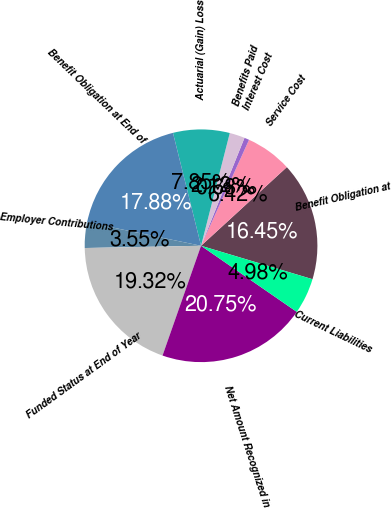Convert chart to OTSL. <chart><loc_0><loc_0><loc_500><loc_500><pie_chart><fcel>Benefit Obligation at<fcel>Service Cost<fcel>Interest Cost<fcel>Benefits Paid<fcel>Actuarial (Gain) Loss<fcel>Benefit Obligation at End of<fcel>Employer Contributions<fcel>Funded Status at End of Year<fcel>Net Amount Recognized in<fcel>Current Liabilities<nl><fcel>16.45%<fcel>6.42%<fcel>0.68%<fcel>2.12%<fcel>7.85%<fcel>17.88%<fcel>3.55%<fcel>19.32%<fcel>20.75%<fcel>4.98%<nl></chart> 